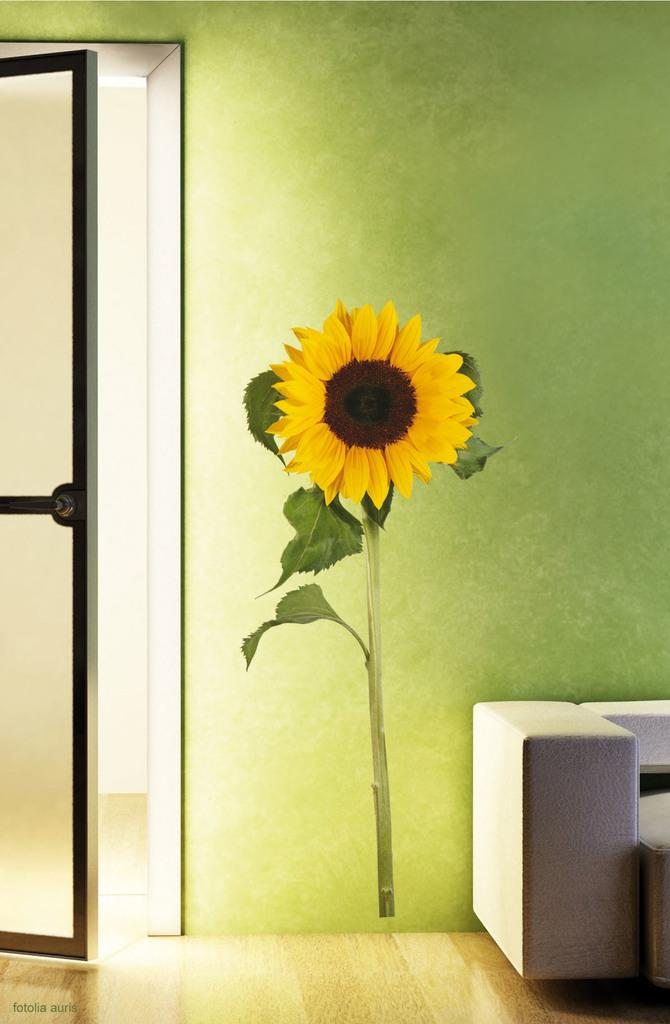What color is the wall in the image? The wall in the image is green. What is depicted on the wall? The wall has a painting of a sunflower. Is there any entrance or exit visible in the image? Yes, there is a door in the image. What can be seen on the floor in the image? There are objects on the floor in the image. How many pears are on the floor in the image? There are no pears present in the image. Can you describe the insects flying around the sunflower painting? There are no insects depicted in the image. 